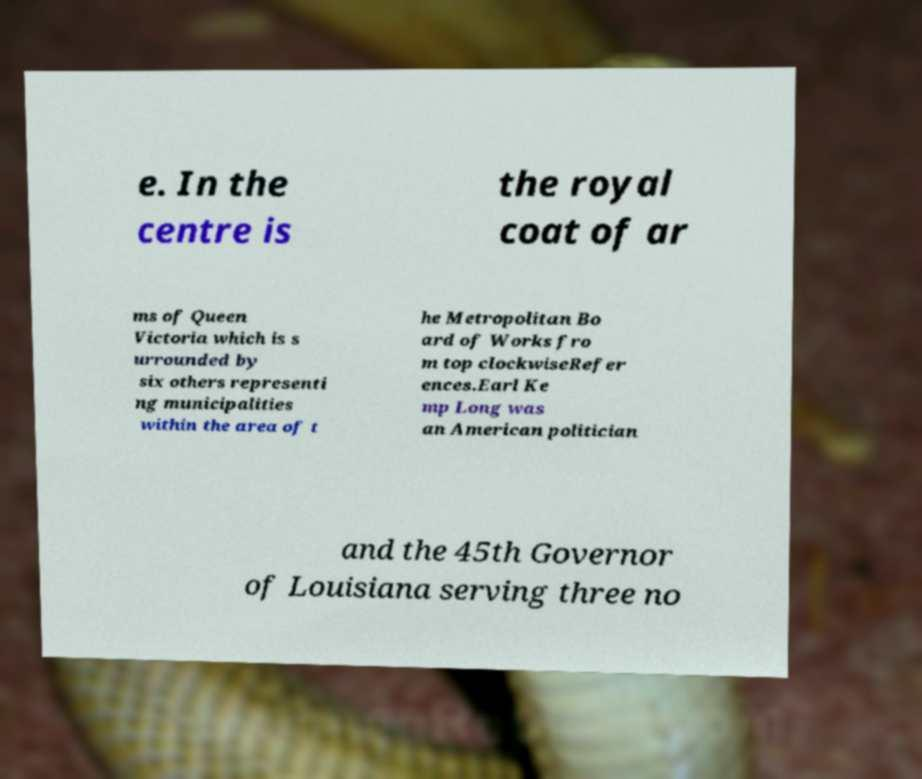For documentation purposes, I need the text within this image transcribed. Could you provide that? e. In the centre is the royal coat of ar ms of Queen Victoria which is s urrounded by six others representi ng municipalities within the area of t he Metropolitan Bo ard of Works fro m top clockwiseRefer ences.Earl Ke mp Long was an American politician and the 45th Governor of Louisiana serving three no 